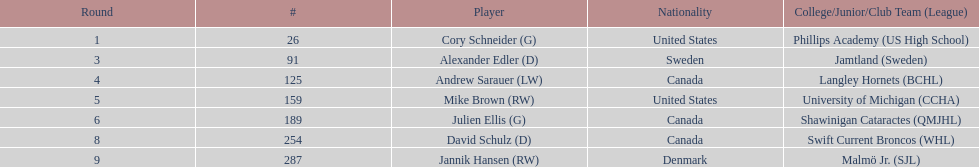What number of players have canada listed as their nationality? 3. 